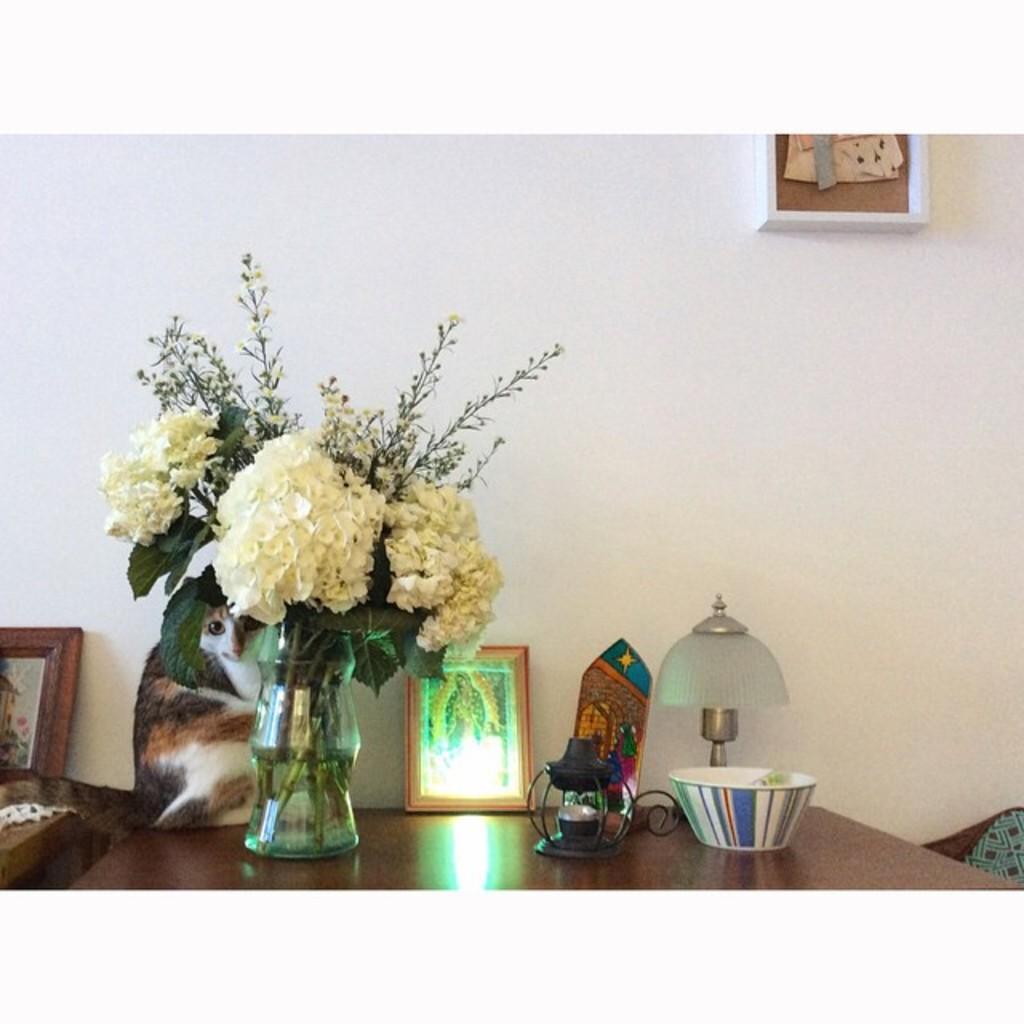How would you summarize this image in a sentence or two? There is a flower vase cat and bowl on table. 